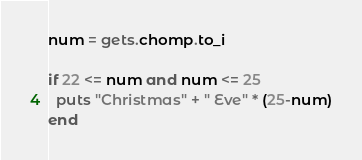Convert code to text. <code><loc_0><loc_0><loc_500><loc_500><_Ruby_>num = gets.chomp.to_i

if 22 <= num and num <= 25
  puts "Christmas" + " Eve" * (25-num)
end</code> 